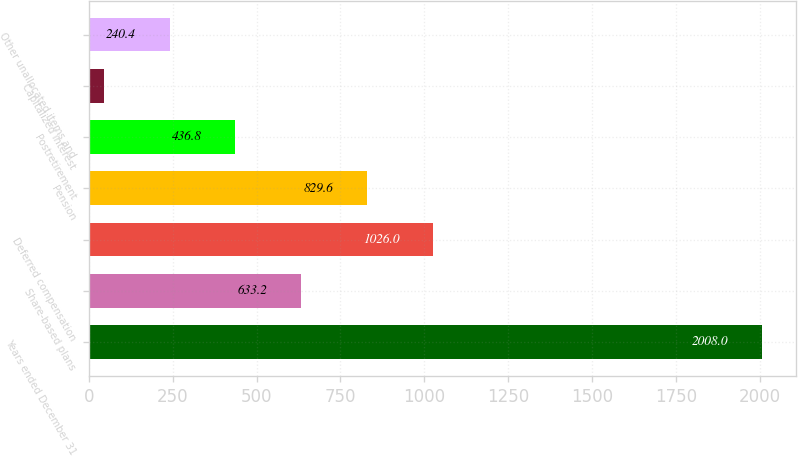Convert chart. <chart><loc_0><loc_0><loc_500><loc_500><bar_chart><fcel>Years ended December 31<fcel>Share-based plans<fcel>Deferred compensation<fcel>Pension<fcel>Postretirement<fcel>Capitalized interest<fcel>Other unallocated items and<nl><fcel>2008<fcel>633.2<fcel>1026<fcel>829.6<fcel>436.8<fcel>44<fcel>240.4<nl></chart> 